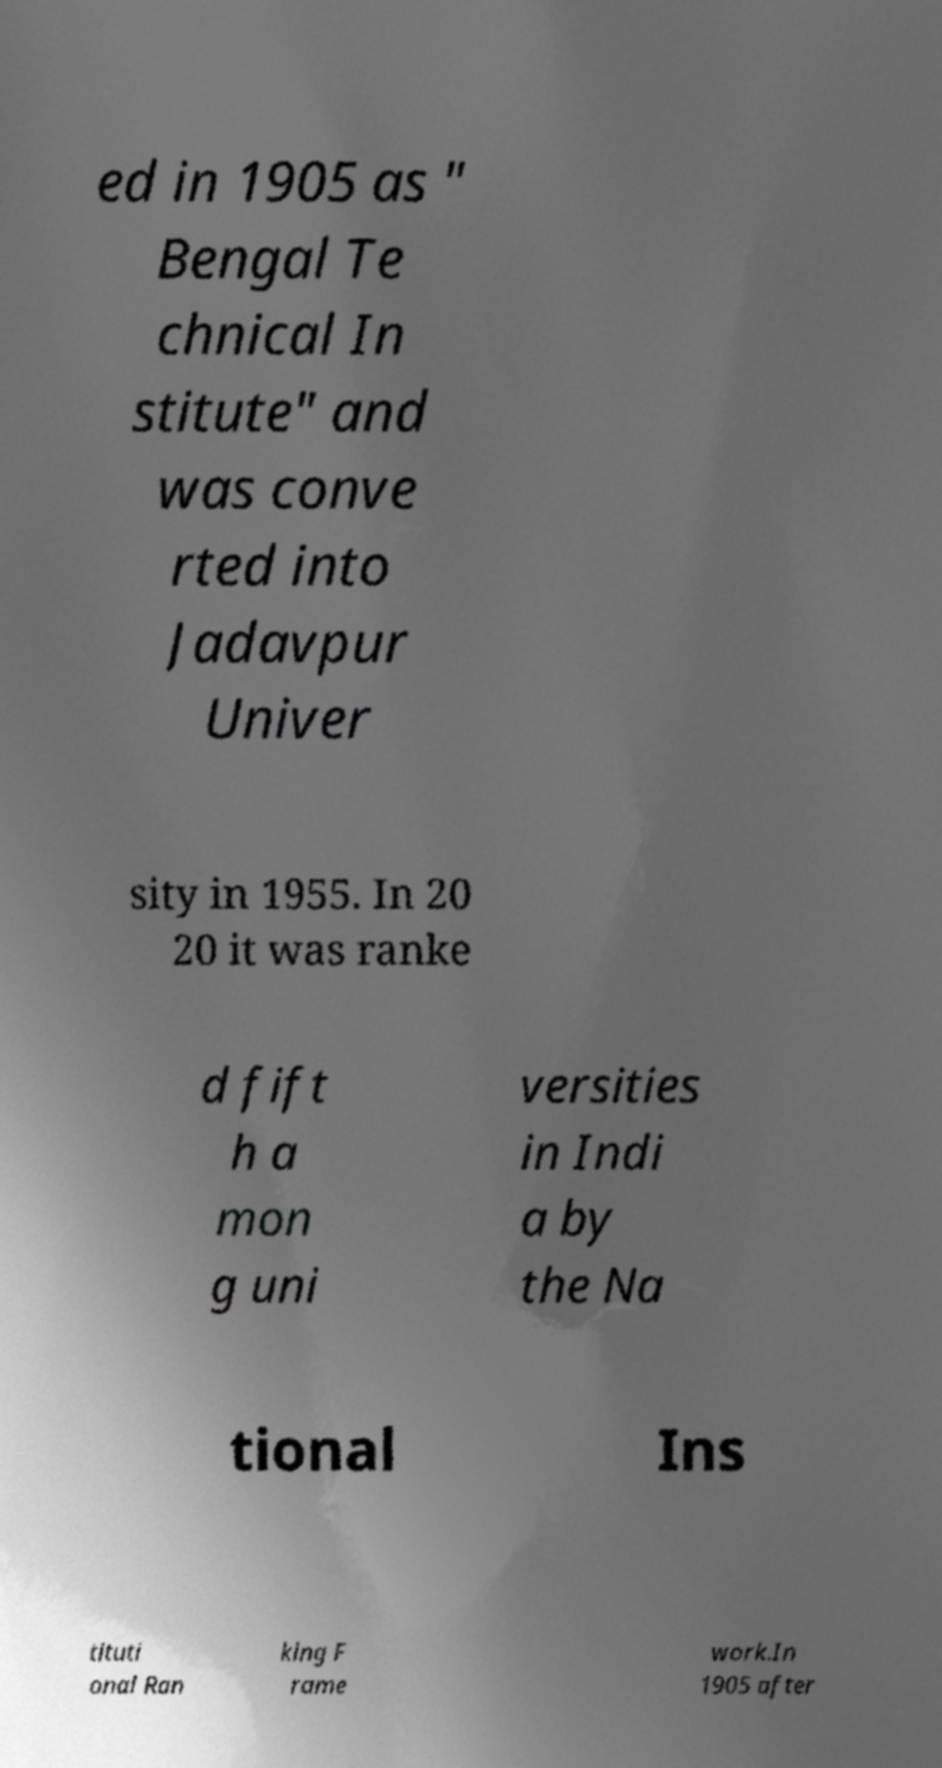Please identify and transcribe the text found in this image. ed in 1905 as " Bengal Te chnical In stitute" and was conve rted into Jadavpur Univer sity in 1955. In 20 20 it was ranke d fift h a mon g uni versities in Indi a by the Na tional Ins tituti onal Ran king F rame work.In 1905 after 